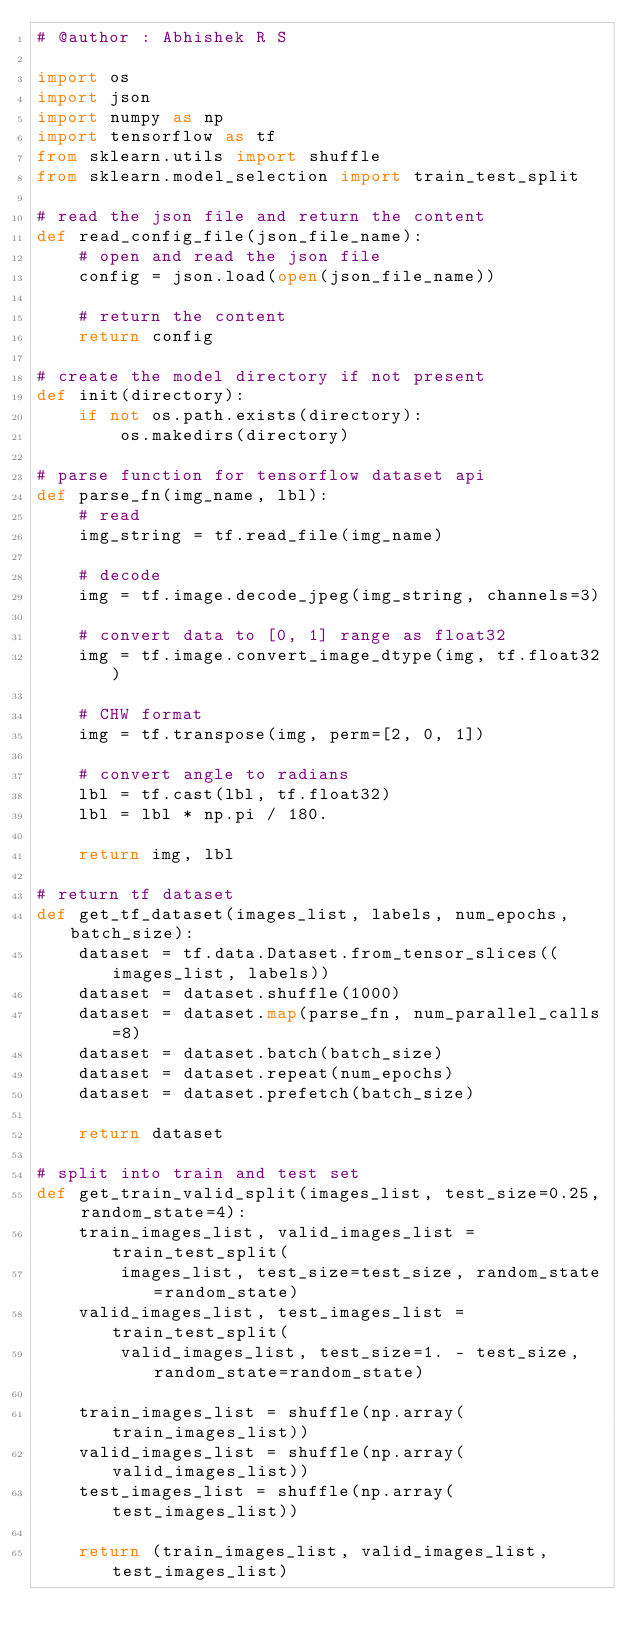<code> <loc_0><loc_0><loc_500><loc_500><_Python_># @author : Abhishek R S

import os
import json
import numpy as np
import tensorflow as tf
from sklearn.utils import shuffle
from sklearn.model_selection import train_test_split

# read the json file and return the content
def read_config_file(json_file_name):
    # open and read the json file
    config = json.load(open(json_file_name))

    # return the content
    return config

# create the model directory if not present
def init(directory):
    if not os.path.exists(directory):
        os.makedirs(directory)

# parse function for tensorflow dataset api
def parse_fn(img_name, lbl):
    # read
    img_string = tf.read_file(img_name)

    # decode
    img = tf.image.decode_jpeg(img_string, channels=3)

    # convert data to [0, 1] range as float32
    img = tf.image.convert_image_dtype(img, tf.float32)

    # CHW format
    img = tf.transpose(img, perm=[2, 0, 1])

    # convert angle to radians
    lbl = tf.cast(lbl, tf.float32)
    lbl = lbl * np.pi / 180.

    return img, lbl

# return tf dataset
def get_tf_dataset(images_list, labels, num_epochs, batch_size):
    dataset = tf.data.Dataset.from_tensor_slices((images_list, labels))
    dataset = dataset.shuffle(1000)
    dataset = dataset.map(parse_fn, num_parallel_calls=8)
    dataset = dataset.batch(batch_size)
    dataset = dataset.repeat(num_epochs)
    dataset = dataset.prefetch(batch_size)

    return dataset

# split into train and test set
def get_train_valid_split(images_list, test_size=0.25, random_state=4):
    train_images_list, valid_images_list = train_test_split(
        images_list, test_size=test_size, random_state=random_state)
    valid_images_list, test_images_list = train_test_split(
        valid_images_list, test_size=1. - test_size, random_state=random_state)

    train_images_list = shuffle(np.array(train_images_list))
    valid_images_list = shuffle(np.array(valid_images_list))
    test_images_list = shuffle(np.array(test_images_list))

    return (train_images_list, valid_images_list, test_images_list)
</code> 